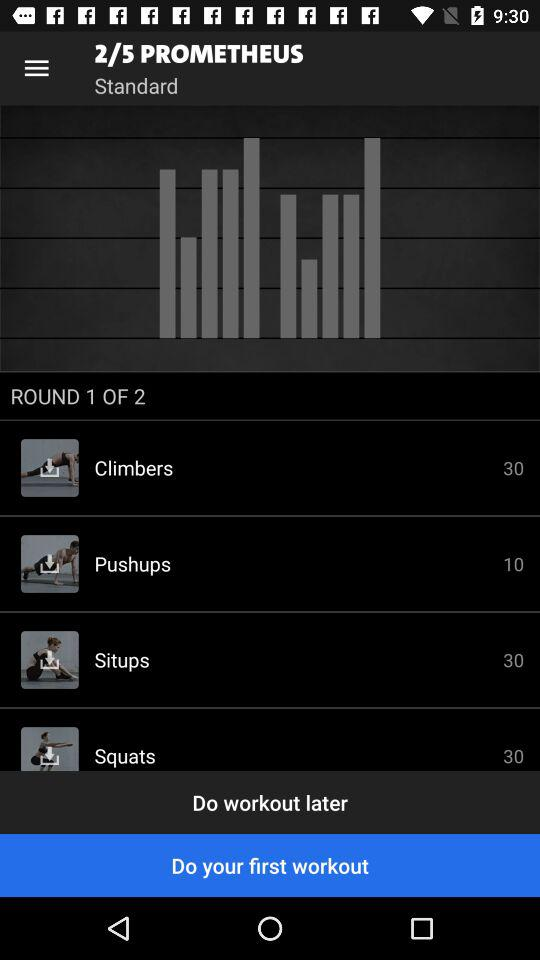Which exercise has a rep count of 10? In the workout list shown in the image, the 'pushups' exercise is set for 10 repetitions, matching your requirement for an exercise with a rep count of 10. This makes it an excellent choice for targeting upper body strength. 